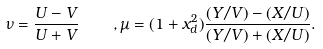<formula> <loc_0><loc_0><loc_500><loc_500>\nu = \frac { U - V } { U + V } \quad , \mu = ( 1 + x _ { d } ^ { 2 } ) \frac { ( Y / V ) - ( X / U ) } { ( Y / V ) + ( X / U ) } .</formula> 